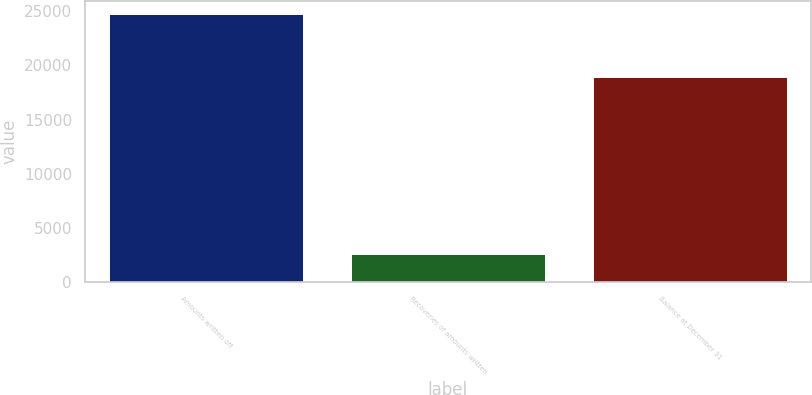<chart> <loc_0><loc_0><loc_500><loc_500><bar_chart><fcel>Amounts written off<fcel>Recoveries of amounts written<fcel>Balance at December 31<nl><fcel>24741<fcel>2566<fcel>18905<nl></chart> 